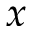Convert formula to latex. <formula><loc_0><loc_0><loc_500><loc_500>x</formula> 